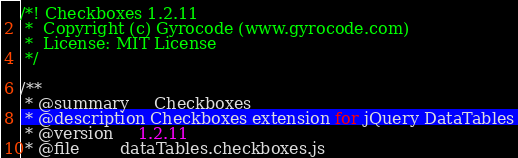<code> <loc_0><loc_0><loc_500><loc_500><_JavaScript_>/*! Checkboxes 1.2.11
 *  Copyright (c) Gyrocode (www.gyrocode.com)
 *  License: MIT License
 */

/**
 * @summary     Checkboxes
 * @description Checkboxes extension for jQuery DataTables
 * @version     1.2.11
 * @file        dataTables.checkboxes.js</code> 